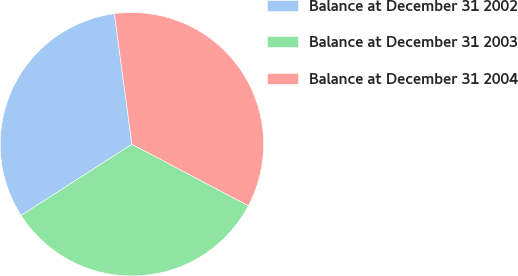Convert chart. <chart><loc_0><loc_0><loc_500><loc_500><pie_chart><fcel>Balance at December 31 2002<fcel>Balance at December 31 2003<fcel>Balance at December 31 2004<nl><fcel>31.97%<fcel>33.18%<fcel>34.86%<nl></chart> 